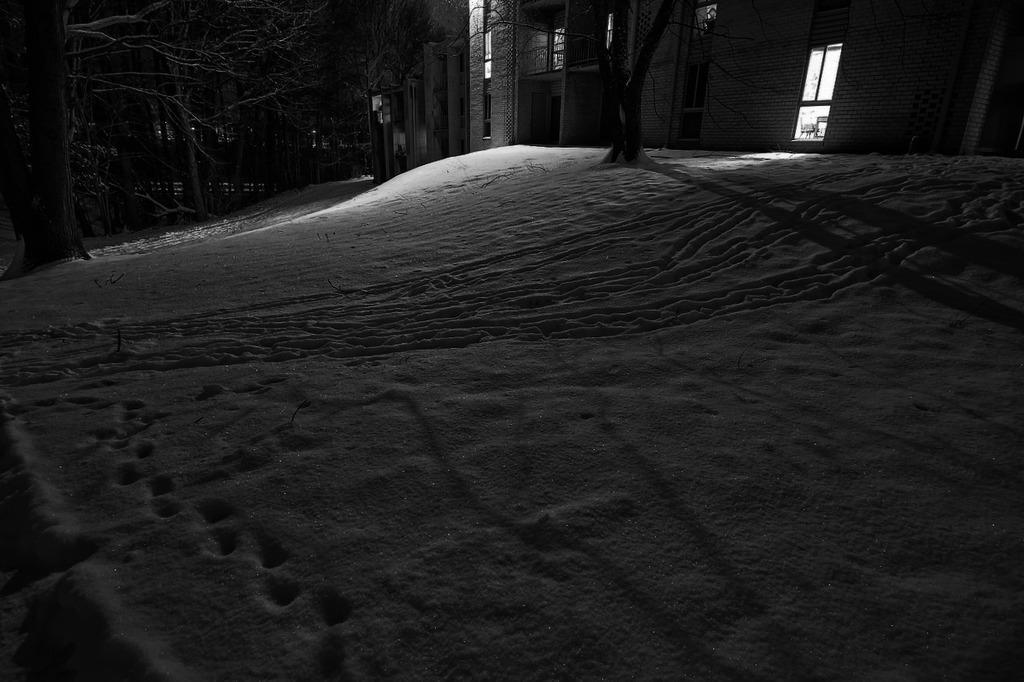Could you give a brief overview of what you see in this image? In the picture we can see a night view of the snow surface area with some trees on it and we can also see some buildings with a window and doors. 